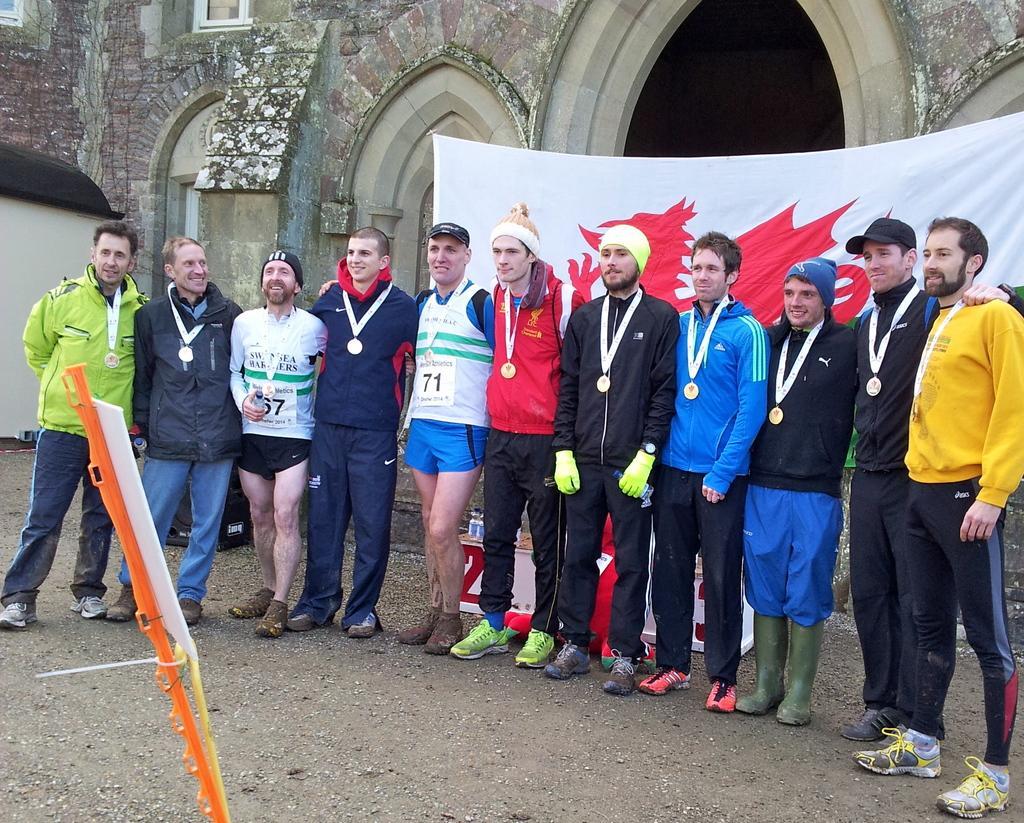Can you describe this image briefly? In this image we can see group of people standing on the ground. In the right side of the image we can see a banner. In the left side of the image we can see a board on a stick. At the top of the image we can see a building with windows. 